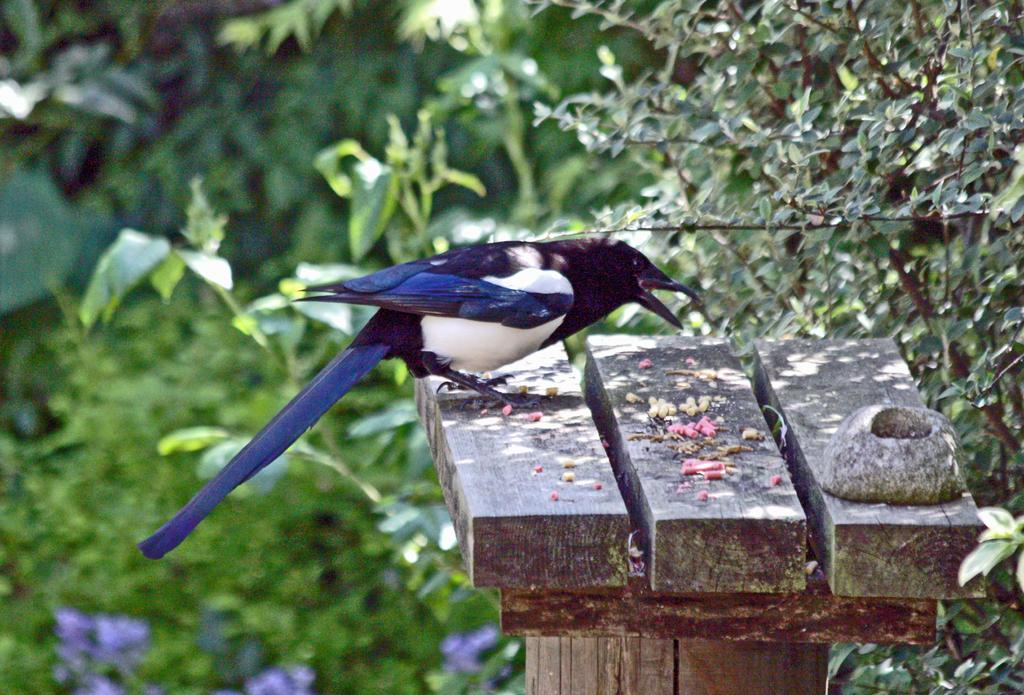What type of animal is in the image? There is a bird in the image. Where is the bird located? The bird is on a wooden object. What can be seen in the background of the image? There are plants with leaves in the background of the image. What type of plants are at the bottom of the image? There are plants with flowers at the bottom of the image. How does the bird help with the birth of new plants in the image? The bird does not help with the birth of new plants in the image; it is simply perched on a wooden object. 